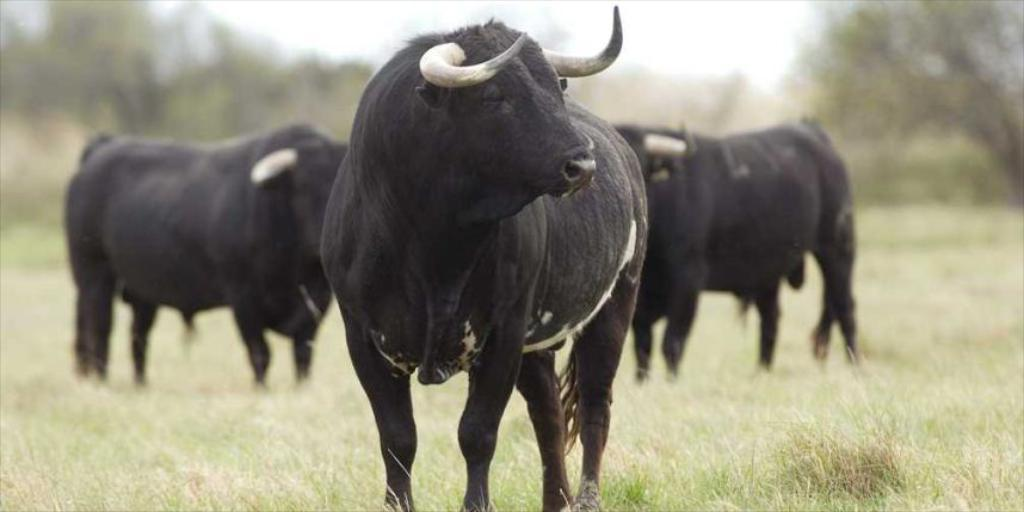What animals are present in the image? There are bulls in the image. What color are the bulls? The bulls are black in color. What type of vegetation can be seen on the ground in the image? There is grass on the ground in the image. Can you describe the background of the image? The background of the image is blurred. How many gallons of blood can be seen spilling from the harbor in the image? There is no harbor or blood present in the image; it features black bulls and grass on the ground. 